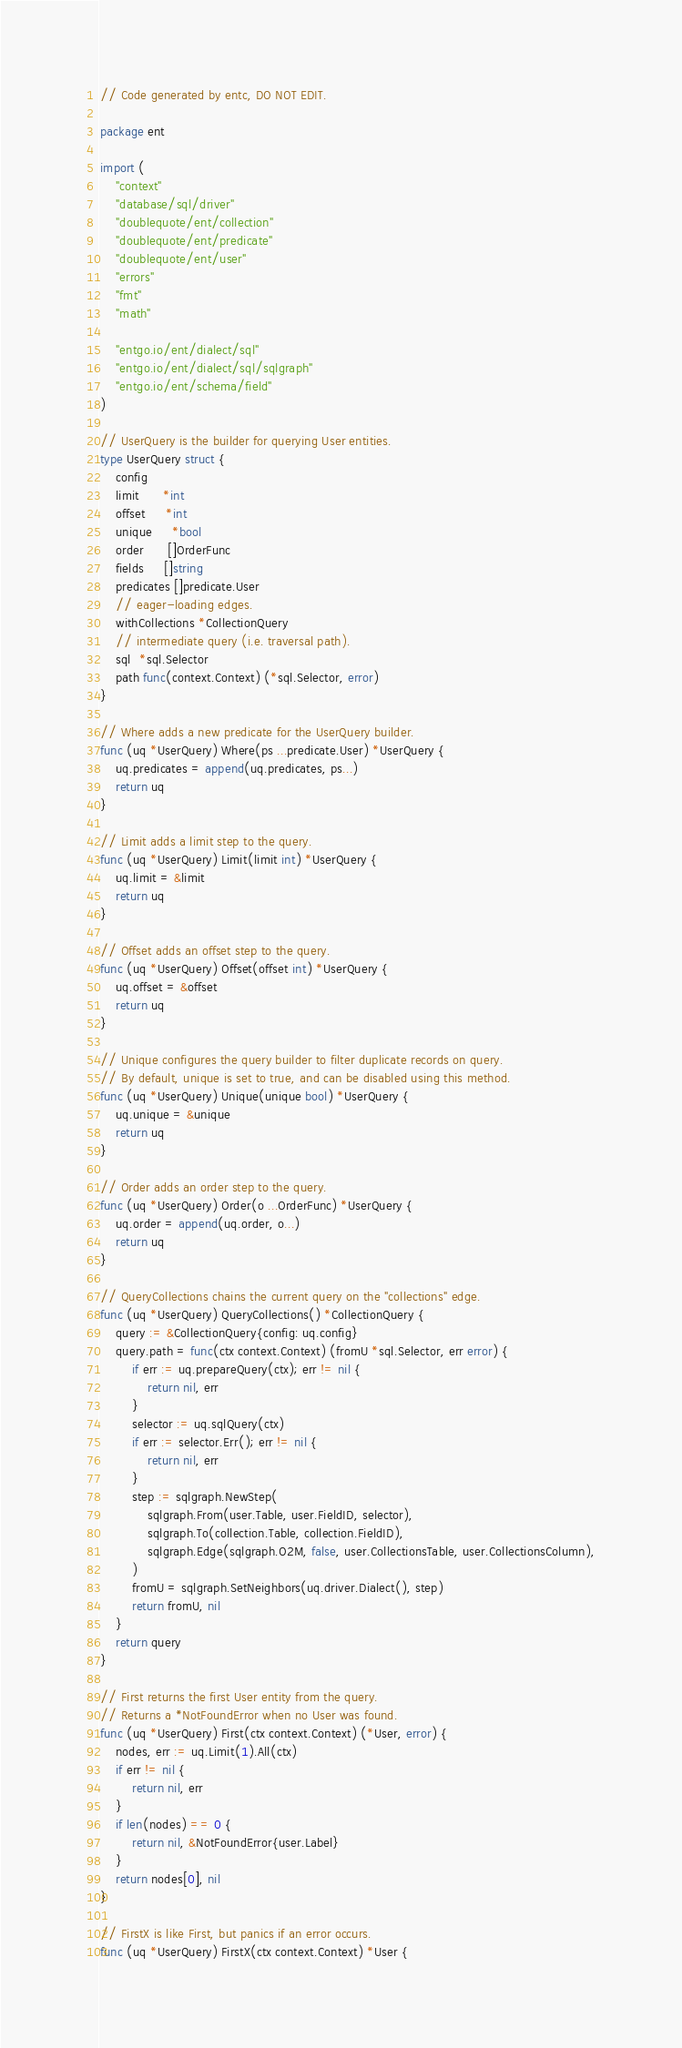Convert code to text. <code><loc_0><loc_0><loc_500><loc_500><_Go_>// Code generated by entc, DO NOT EDIT.

package ent

import (
	"context"
	"database/sql/driver"
	"doublequote/ent/collection"
	"doublequote/ent/predicate"
	"doublequote/ent/user"
	"errors"
	"fmt"
	"math"

	"entgo.io/ent/dialect/sql"
	"entgo.io/ent/dialect/sql/sqlgraph"
	"entgo.io/ent/schema/field"
)

// UserQuery is the builder for querying User entities.
type UserQuery struct {
	config
	limit      *int
	offset     *int
	unique     *bool
	order      []OrderFunc
	fields     []string
	predicates []predicate.User
	// eager-loading edges.
	withCollections *CollectionQuery
	// intermediate query (i.e. traversal path).
	sql  *sql.Selector
	path func(context.Context) (*sql.Selector, error)
}

// Where adds a new predicate for the UserQuery builder.
func (uq *UserQuery) Where(ps ...predicate.User) *UserQuery {
	uq.predicates = append(uq.predicates, ps...)
	return uq
}

// Limit adds a limit step to the query.
func (uq *UserQuery) Limit(limit int) *UserQuery {
	uq.limit = &limit
	return uq
}

// Offset adds an offset step to the query.
func (uq *UserQuery) Offset(offset int) *UserQuery {
	uq.offset = &offset
	return uq
}

// Unique configures the query builder to filter duplicate records on query.
// By default, unique is set to true, and can be disabled using this method.
func (uq *UserQuery) Unique(unique bool) *UserQuery {
	uq.unique = &unique
	return uq
}

// Order adds an order step to the query.
func (uq *UserQuery) Order(o ...OrderFunc) *UserQuery {
	uq.order = append(uq.order, o...)
	return uq
}

// QueryCollections chains the current query on the "collections" edge.
func (uq *UserQuery) QueryCollections() *CollectionQuery {
	query := &CollectionQuery{config: uq.config}
	query.path = func(ctx context.Context) (fromU *sql.Selector, err error) {
		if err := uq.prepareQuery(ctx); err != nil {
			return nil, err
		}
		selector := uq.sqlQuery(ctx)
		if err := selector.Err(); err != nil {
			return nil, err
		}
		step := sqlgraph.NewStep(
			sqlgraph.From(user.Table, user.FieldID, selector),
			sqlgraph.To(collection.Table, collection.FieldID),
			sqlgraph.Edge(sqlgraph.O2M, false, user.CollectionsTable, user.CollectionsColumn),
		)
		fromU = sqlgraph.SetNeighbors(uq.driver.Dialect(), step)
		return fromU, nil
	}
	return query
}

// First returns the first User entity from the query.
// Returns a *NotFoundError when no User was found.
func (uq *UserQuery) First(ctx context.Context) (*User, error) {
	nodes, err := uq.Limit(1).All(ctx)
	if err != nil {
		return nil, err
	}
	if len(nodes) == 0 {
		return nil, &NotFoundError{user.Label}
	}
	return nodes[0], nil
}

// FirstX is like First, but panics if an error occurs.
func (uq *UserQuery) FirstX(ctx context.Context) *User {</code> 